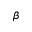<formula> <loc_0><loc_0><loc_500><loc_500>\beta</formula> 